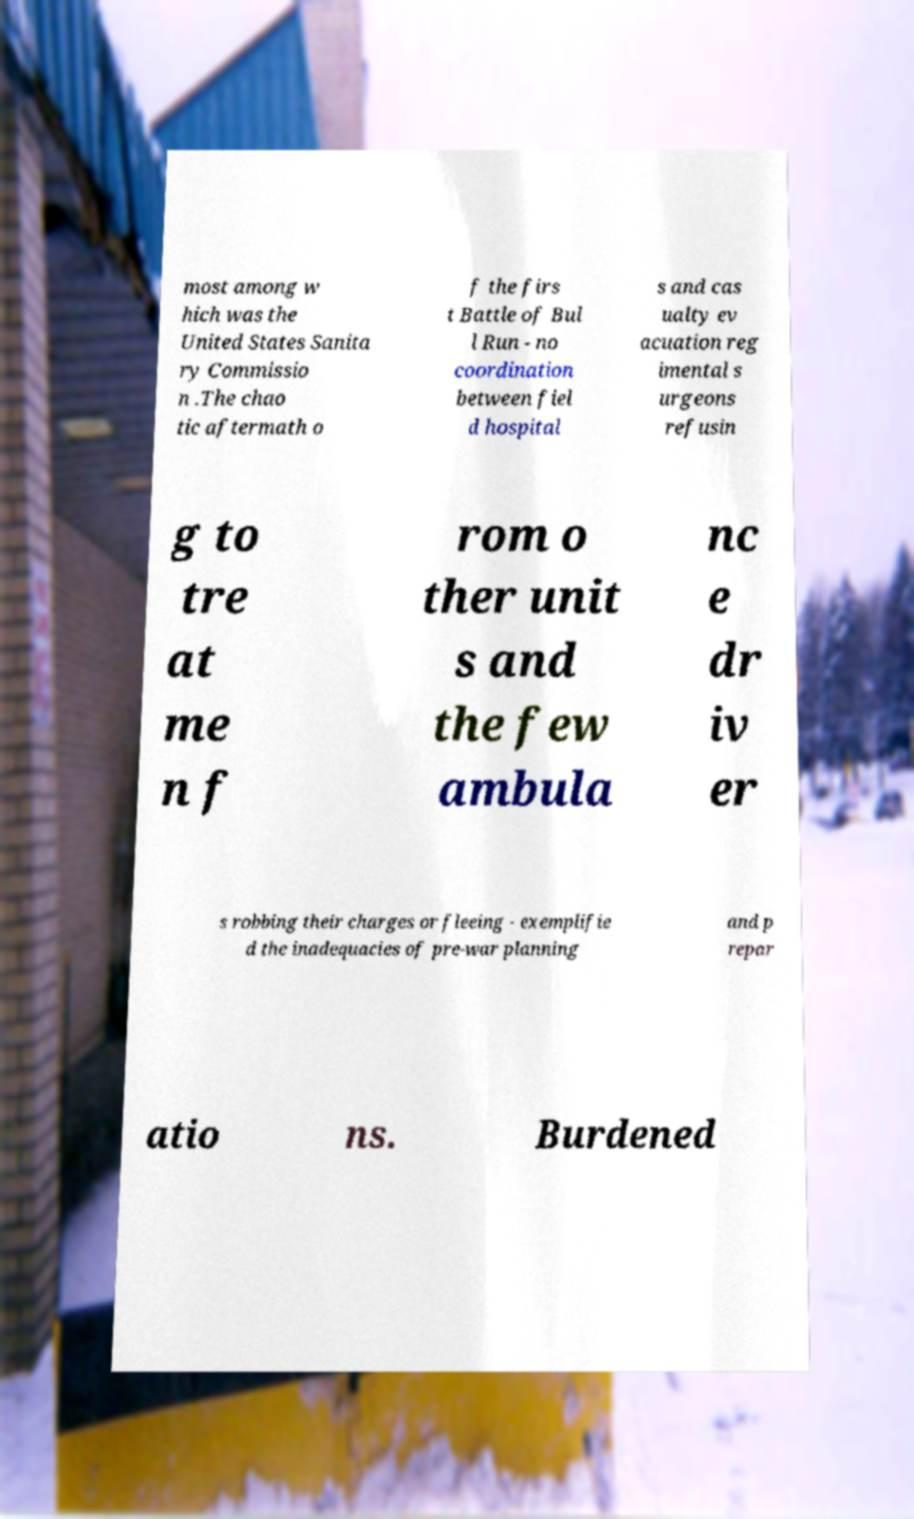For documentation purposes, I need the text within this image transcribed. Could you provide that? most among w hich was the United States Sanita ry Commissio n .The chao tic aftermath o f the firs t Battle of Bul l Run - no coordination between fiel d hospital s and cas ualty ev acuation reg imental s urgeons refusin g to tre at me n f rom o ther unit s and the few ambula nc e dr iv er s robbing their charges or fleeing - exemplifie d the inadequacies of pre-war planning and p repar atio ns. Burdened 